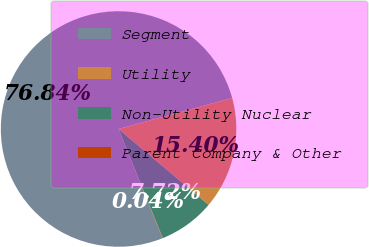Convert chart. <chart><loc_0><loc_0><loc_500><loc_500><pie_chart><fcel>Segment<fcel>Utility<fcel>Non-Utility Nuclear<fcel>Parent Company & Other<nl><fcel>76.84%<fcel>15.4%<fcel>7.72%<fcel>0.04%<nl></chart> 